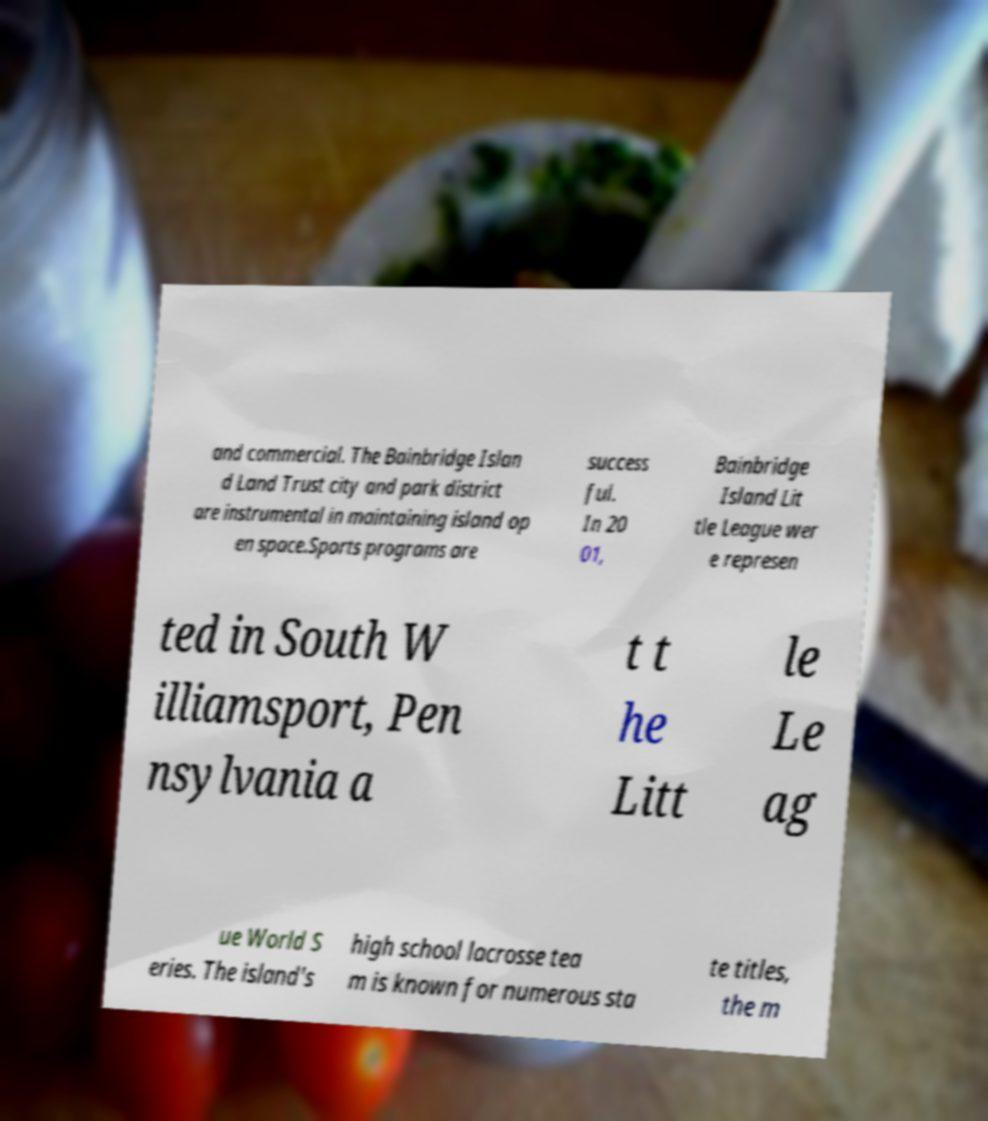Can you accurately transcribe the text from the provided image for me? and commercial. The Bainbridge Islan d Land Trust city and park district are instrumental in maintaining island op en space.Sports programs are success ful. In 20 01, Bainbridge Island Lit tle League wer e represen ted in South W illiamsport, Pen nsylvania a t t he Litt le Le ag ue World S eries. The island's high school lacrosse tea m is known for numerous sta te titles, the m 